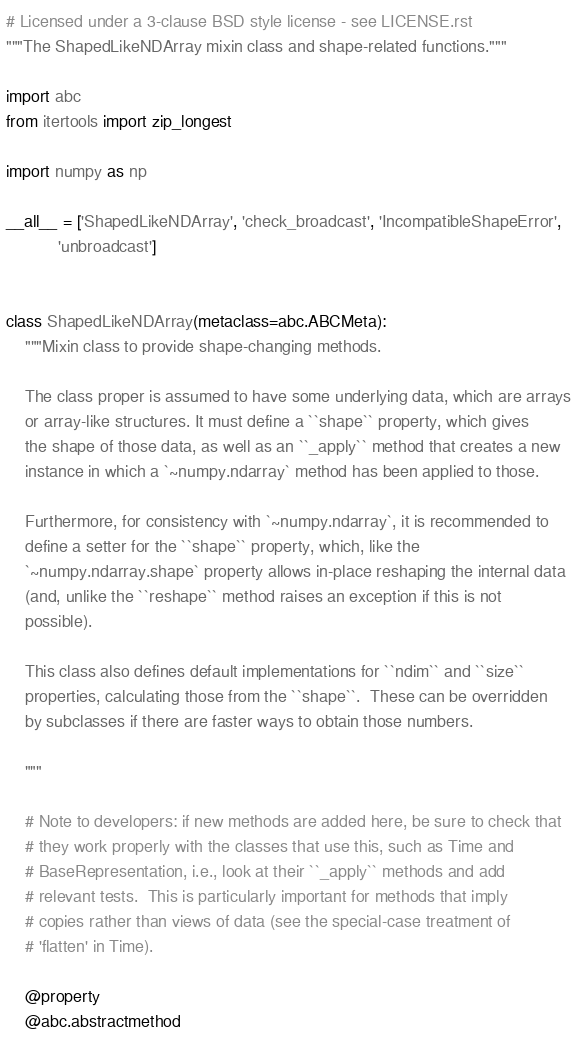Convert code to text. <code><loc_0><loc_0><loc_500><loc_500><_Python_># Licensed under a 3-clause BSD style license - see LICENSE.rst
"""The ShapedLikeNDArray mixin class and shape-related functions."""

import abc
from itertools import zip_longest

import numpy as np

__all__ = ['ShapedLikeNDArray', 'check_broadcast', 'IncompatibleShapeError',
           'unbroadcast']


class ShapedLikeNDArray(metaclass=abc.ABCMeta):
    """Mixin class to provide shape-changing methods.

    The class proper is assumed to have some underlying data, which are arrays
    or array-like structures. It must define a ``shape`` property, which gives
    the shape of those data, as well as an ``_apply`` method that creates a new
    instance in which a `~numpy.ndarray` method has been applied to those.

    Furthermore, for consistency with `~numpy.ndarray`, it is recommended to
    define a setter for the ``shape`` property, which, like the
    `~numpy.ndarray.shape` property allows in-place reshaping the internal data
    (and, unlike the ``reshape`` method raises an exception if this is not
    possible).

    This class also defines default implementations for ``ndim`` and ``size``
    properties, calculating those from the ``shape``.  These can be overridden
    by subclasses if there are faster ways to obtain those numbers.

    """

    # Note to developers: if new methods are added here, be sure to check that
    # they work properly with the classes that use this, such as Time and
    # BaseRepresentation, i.e., look at their ``_apply`` methods and add
    # relevant tests.  This is particularly important for methods that imply
    # copies rather than views of data (see the special-case treatment of
    # 'flatten' in Time).

    @property
    @abc.abstractmethod</code> 